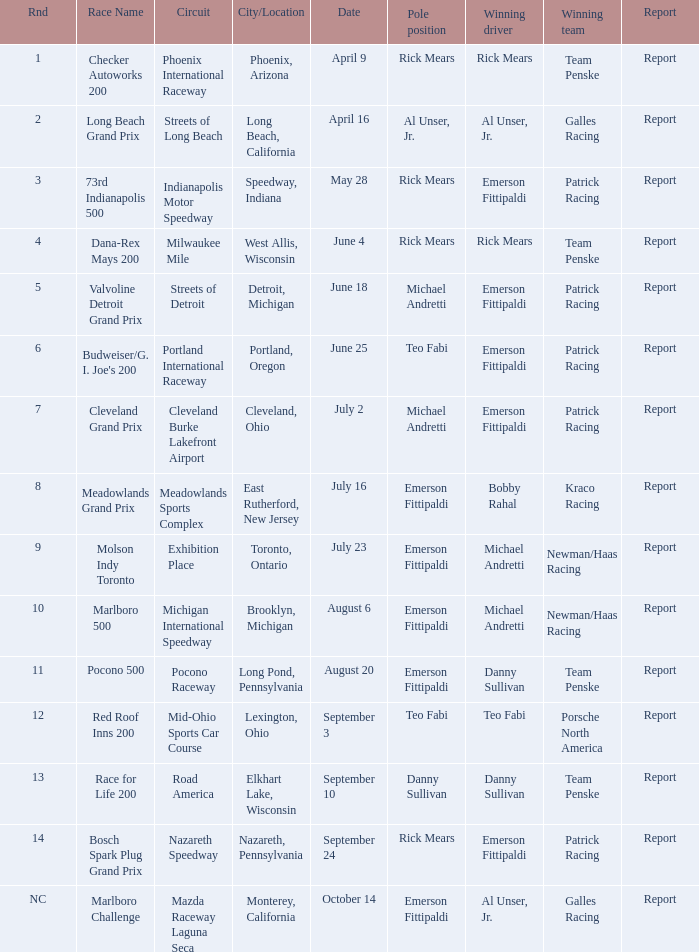What rnds were there for the phoenix international raceway? 1.0. 